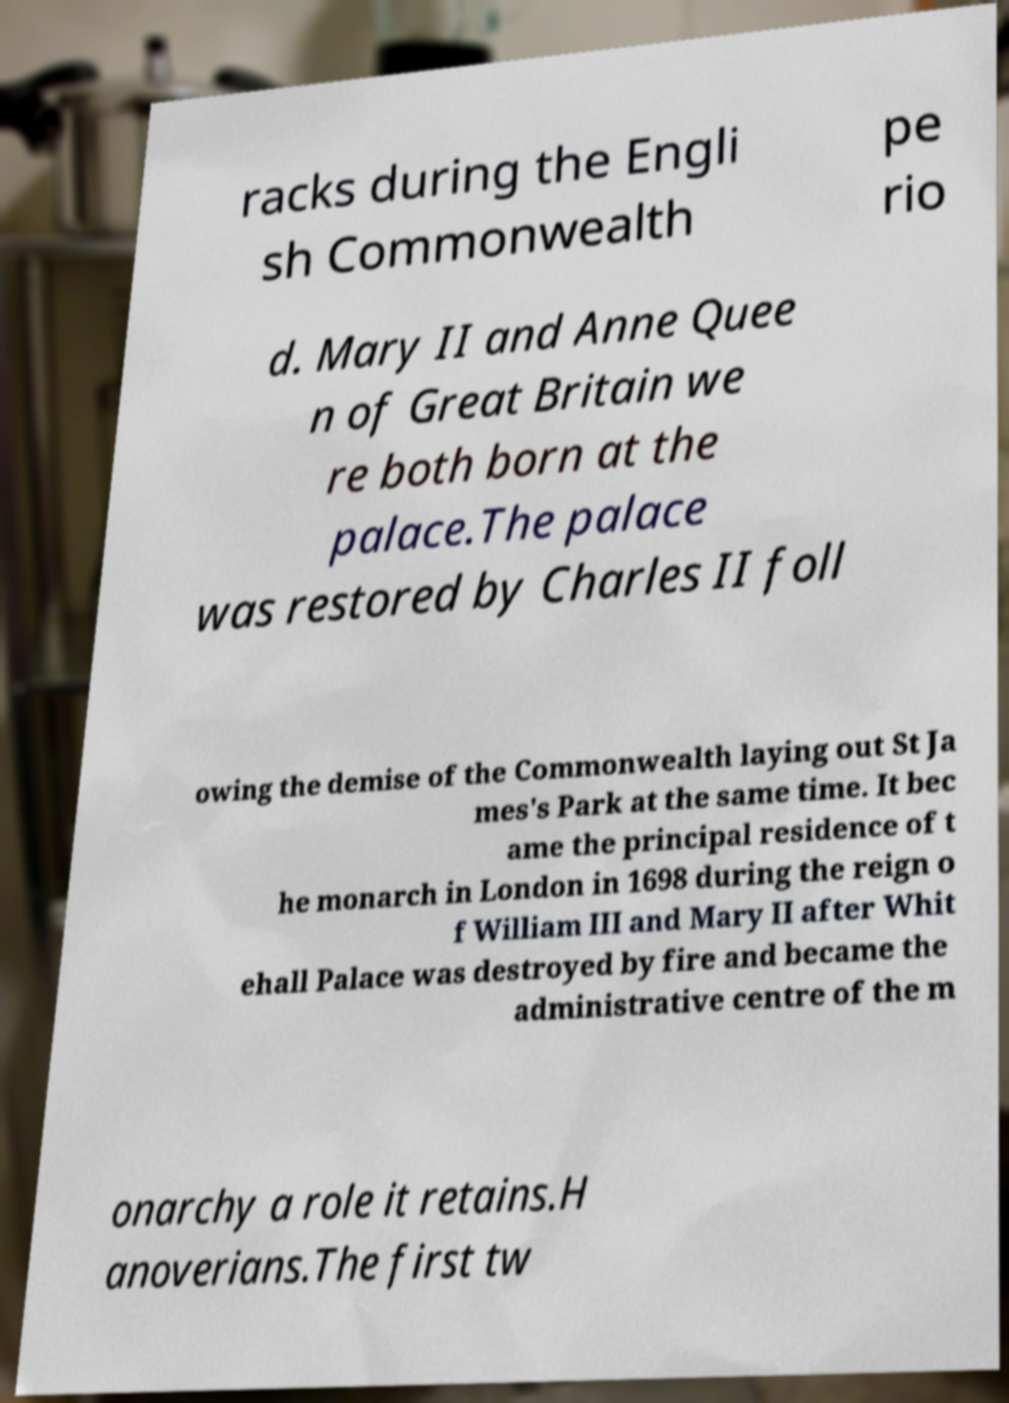For documentation purposes, I need the text within this image transcribed. Could you provide that? racks during the Engli sh Commonwealth pe rio d. Mary II and Anne Quee n of Great Britain we re both born at the palace.The palace was restored by Charles II foll owing the demise of the Commonwealth laying out St Ja mes's Park at the same time. It bec ame the principal residence of t he monarch in London in 1698 during the reign o f William III and Mary II after Whit ehall Palace was destroyed by fire and became the administrative centre of the m onarchy a role it retains.H anoverians.The first tw 